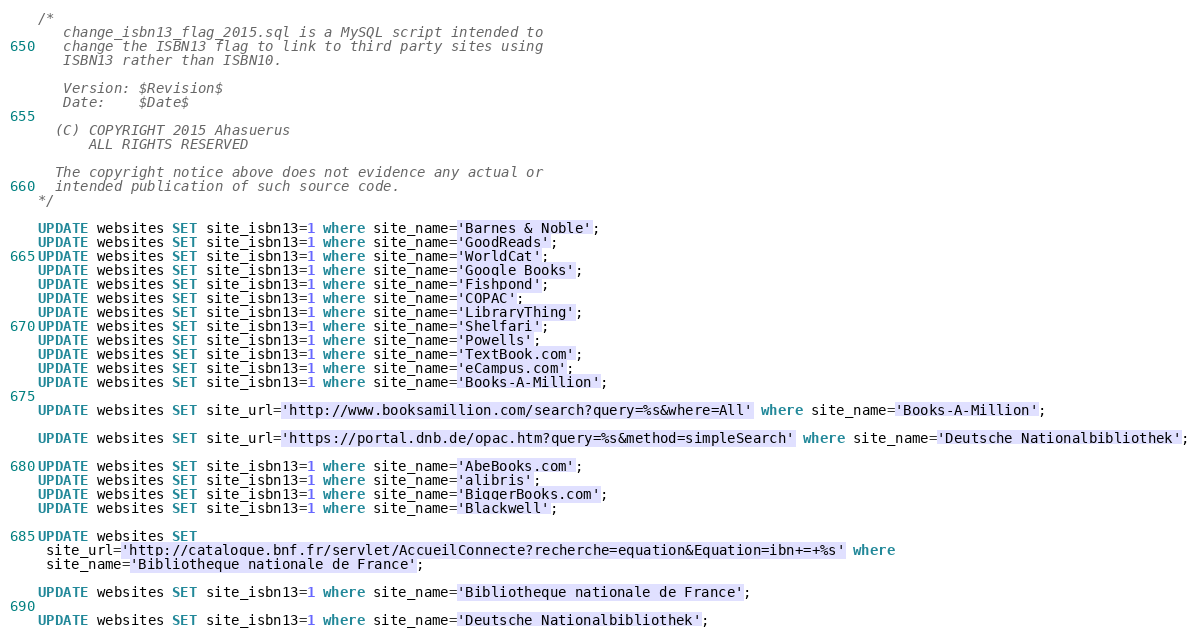Convert code to text. <code><loc_0><loc_0><loc_500><loc_500><_SQL_>/* 
   change_isbn13_flag_2015.sql is a MySQL script intended to  
   change the ISBN13 flag to link to third party sites using
   ISBN13 rather than ISBN10.

   Version: $Revision$
   Date:    $Date$

  (C) COPYRIGHT 2015 Ahasuerus
      ALL RIGHTS RESERVED

  The copyright notice above does not evidence any actual or
  intended publication of such source code.
*/

UPDATE websites SET site_isbn13=1 where site_name='Barnes & Noble';
UPDATE websites SET site_isbn13=1 where site_name='GoodReads';
UPDATE websites SET site_isbn13=1 where site_name='WorldCat';
UPDATE websites SET site_isbn13=1 where site_name='Google Books';
UPDATE websites SET site_isbn13=1 where site_name='Fishpond';
UPDATE websites SET site_isbn13=1 where site_name='COPAC';
UPDATE websites SET site_isbn13=1 where site_name='LibraryThing';
UPDATE websites SET site_isbn13=1 where site_name='Shelfari';
UPDATE websites SET site_isbn13=1 where site_name='Powells';
UPDATE websites SET site_isbn13=1 where site_name='TextBook.com';
UPDATE websites SET site_isbn13=1 where site_name='eCampus.com';
UPDATE websites SET site_isbn13=1 where site_name='Books-A-Million';

UPDATE websites SET site_url='http://www.booksamillion.com/search?query=%s&where=All' where site_name='Books-A-Million';

UPDATE websites SET site_url='https://portal.dnb.de/opac.htm?query=%s&method=simpleSearch' where site_name='Deutsche Nationalbibliothek';

UPDATE websites SET site_isbn13=1 where site_name='AbeBooks.com';
UPDATE websites SET site_isbn13=1 where site_name='alibris';
UPDATE websites SET site_isbn13=1 where site_name='BiggerBooks.com';
UPDATE websites SET site_isbn13=1 where site_name='Blackwell';

UPDATE websites SET
 site_url='http://catalogue.bnf.fr/servlet/AccueilConnecte?recherche=equation&Equation=ibn+=+%s' where
 site_name='Bibliotheque nationale de France';

UPDATE websites SET site_isbn13=1 where site_name='Bibliotheque nationale de France';

UPDATE websites SET site_isbn13=1 where site_name='Deutsche Nationalbibliothek';
</code> 